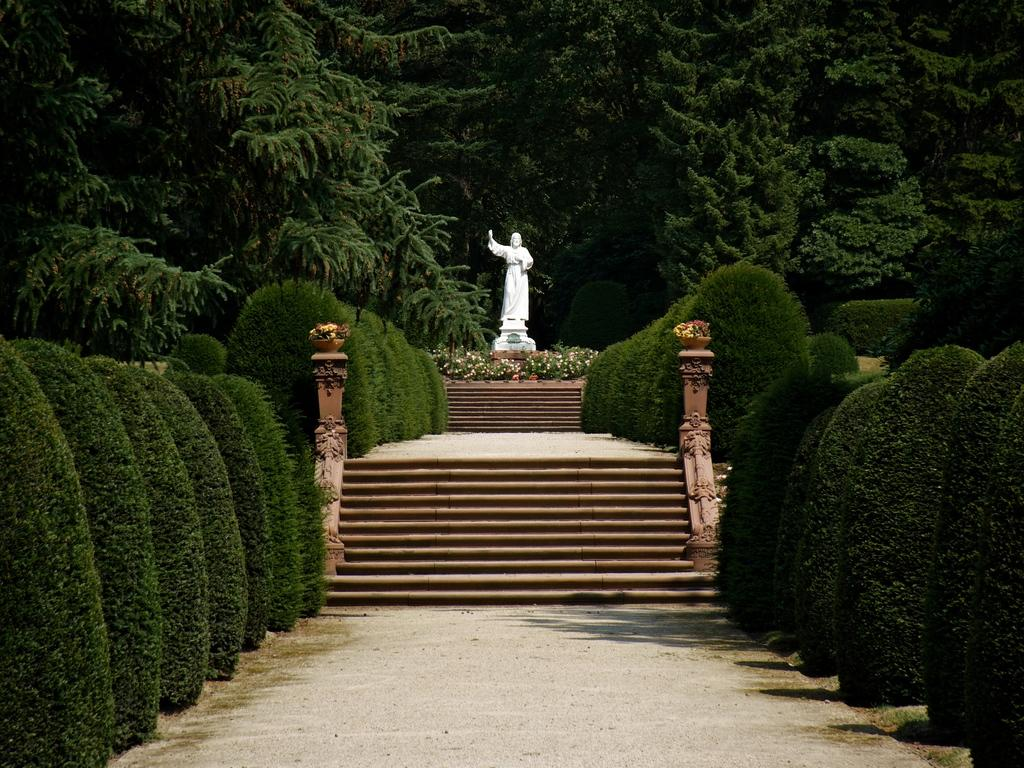What is the main subject of the image? There is a sculpture in the image. What other elements can be seen in the image? There are flowers, trees, plants, and stairs in the image. What type of thread is being used to create the nest in the image? There is no nest present in the image; it features a sculpture, flowers, trees, plants, and stairs. 